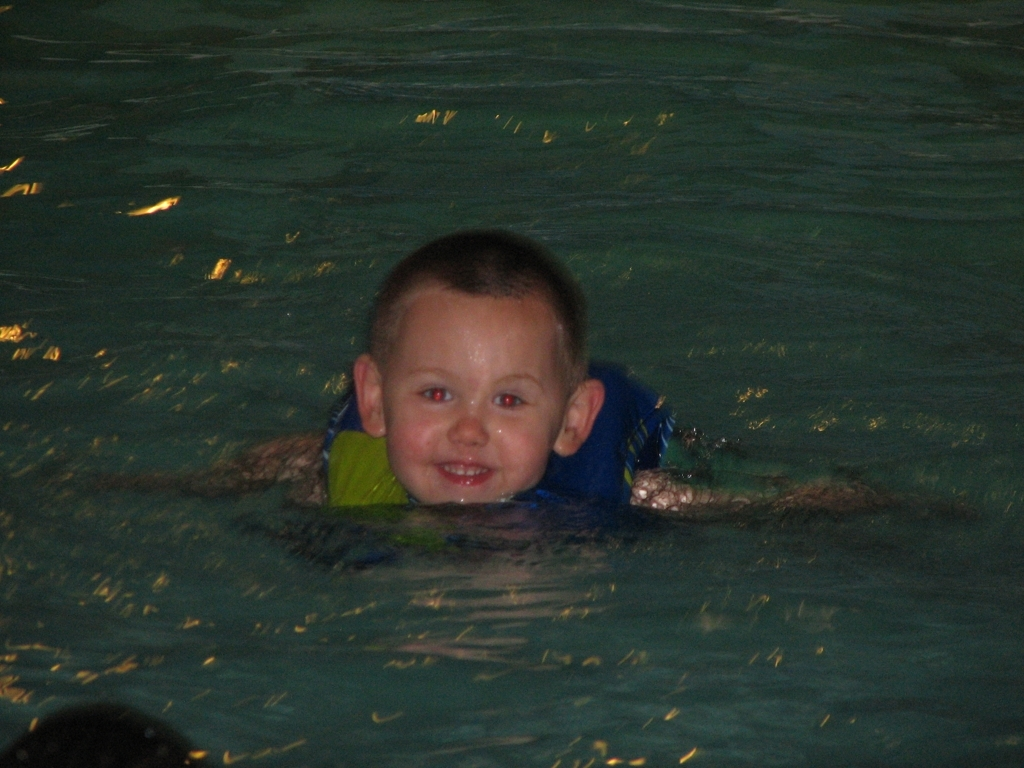Is the image blurry?
A. Yes
B. No
Answer with the option's letter from the given choices directly.
 B. 